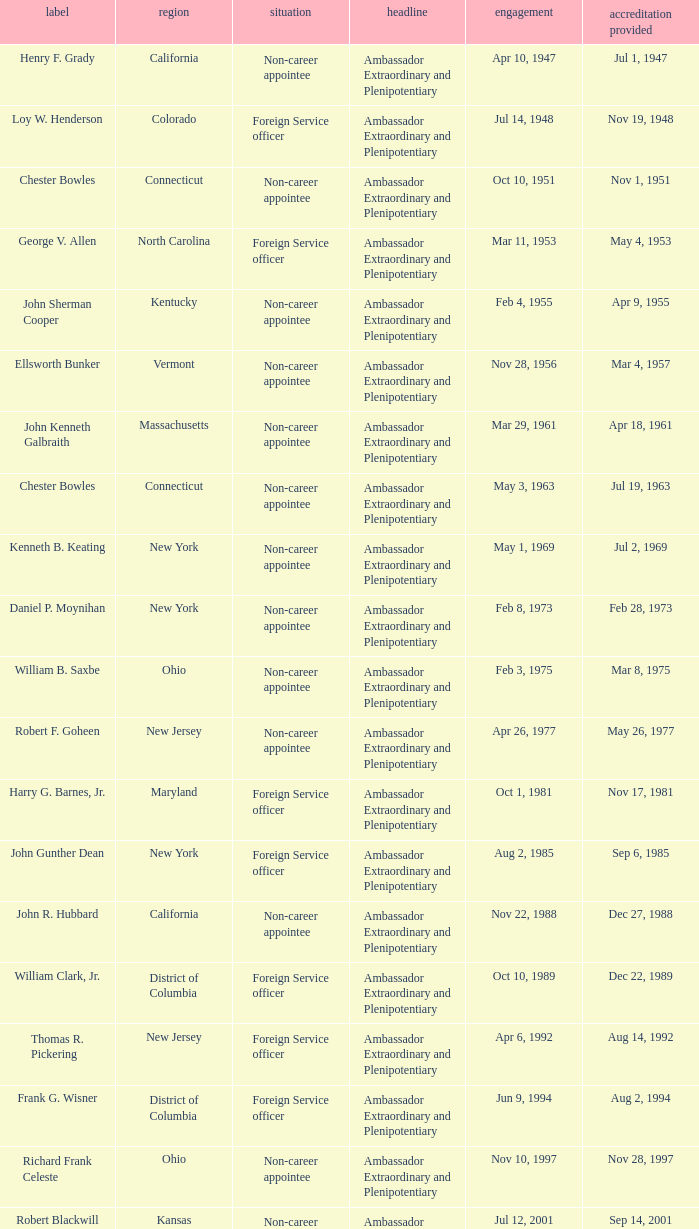When were the credentials presented for new jersey with a status of foreign service officer? Aug 14, 1992. 